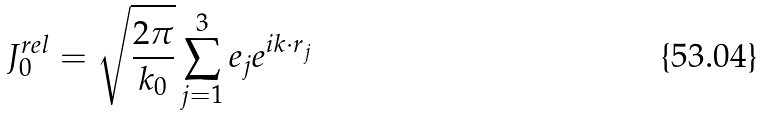<formula> <loc_0><loc_0><loc_500><loc_500>J _ { 0 } ^ { r e l } = \sqrt { \frac { 2 \pi } { k _ { 0 } } } \sum _ { j = 1 } ^ { 3 } e _ { j } e ^ { i { k \cdot r } _ { j } }</formula> 